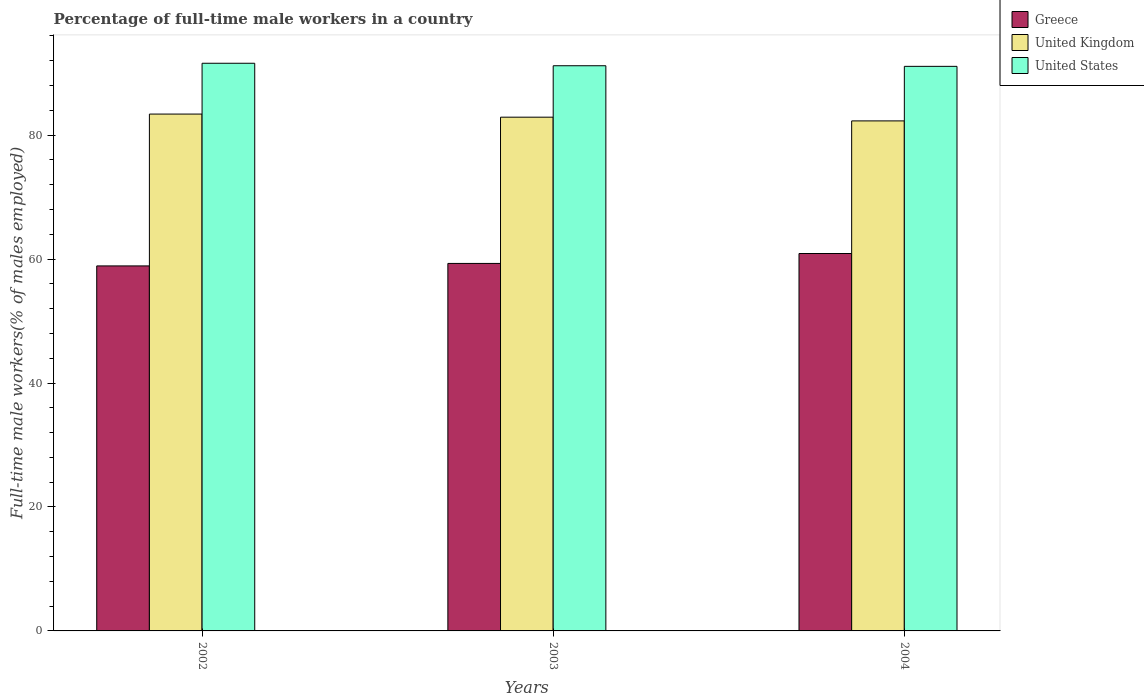How many groups of bars are there?
Give a very brief answer. 3. Are the number of bars per tick equal to the number of legend labels?
Your response must be concise. Yes. What is the percentage of full-time male workers in United Kingdom in 2003?
Provide a succinct answer. 82.9. Across all years, what is the maximum percentage of full-time male workers in Greece?
Provide a succinct answer. 60.9. Across all years, what is the minimum percentage of full-time male workers in United Kingdom?
Ensure brevity in your answer.  82.3. In which year was the percentage of full-time male workers in United States maximum?
Provide a short and direct response. 2002. In which year was the percentage of full-time male workers in United Kingdom minimum?
Your response must be concise. 2004. What is the total percentage of full-time male workers in United States in the graph?
Provide a succinct answer. 273.9. What is the difference between the percentage of full-time male workers in Greece in 2003 and the percentage of full-time male workers in United Kingdom in 2004?
Keep it short and to the point. -23. What is the average percentage of full-time male workers in United States per year?
Give a very brief answer. 91.3. In the year 2002, what is the difference between the percentage of full-time male workers in United States and percentage of full-time male workers in Greece?
Offer a very short reply. 32.7. In how many years, is the percentage of full-time male workers in Greece greater than 56 %?
Keep it short and to the point. 3. What is the ratio of the percentage of full-time male workers in Greece in 2002 to that in 2003?
Offer a terse response. 0.99. Is the percentage of full-time male workers in United Kingdom in 2003 less than that in 2004?
Offer a terse response. No. Is the difference between the percentage of full-time male workers in United States in 2002 and 2003 greater than the difference between the percentage of full-time male workers in Greece in 2002 and 2003?
Your answer should be compact. Yes. What is the difference between the highest and the second highest percentage of full-time male workers in Greece?
Ensure brevity in your answer.  1.6. What does the 2nd bar from the left in 2002 represents?
Provide a short and direct response. United Kingdom. How many bars are there?
Provide a short and direct response. 9. Are all the bars in the graph horizontal?
Offer a very short reply. No. What is the difference between two consecutive major ticks on the Y-axis?
Provide a short and direct response. 20. Does the graph contain grids?
Give a very brief answer. No. Where does the legend appear in the graph?
Your response must be concise. Top right. How many legend labels are there?
Give a very brief answer. 3. How are the legend labels stacked?
Keep it short and to the point. Vertical. What is the title of the graph?
Offer a very short reply. Percentage of full-time male workers in a country. Does "Iraq" appear as one of the legend labels in the graph?
Keep it short and to the point. No. What is the label or title of the X-axis?
Make the answer very short. Years. What is the label or title of the Y-axis?
Provide a short and direct response. Full-time male workers(% of males employed). What is the Full-time male workers(% of males employed) of Greece in 2002?
Ensure brevity in your answer.  58.9. What is the Full-time male workers(% of males employed) of United Kingdom in 2002?
Keep it short and to the point. 83.4. What is the Full-time male workers(% of males employed) of United States in 2002?
Offer a very short reply. 91.6. What is the Full-time male workers(% of males employed) in Greece in 2003?
Make the answer very short. 59.3. What is the Full-time male workers(% of males employed) in United Kingdom in 2003?
Make the answer very short. 82.9. What is the Full-time male workers(% of males employed) of United States in 2003?
Offer a very short reply. 91.2. What is the Full-time male workers(% of males employed) of Greece in 2004?
Provide a short and direct response. 60.9. What is the Full-time male workers(% of males employed) of United Kingdom in 2004?
Ensure brevity in your answer.  82.3. What is the Full-time male workers(% of males employed) in United States in 2004?
Offer a very short reply. 91.1. Across all years, what is the maximum Full-time male workers(% of males employed) in Greece?
Provide a succinct answer. 60.9. Across all years, what is the maximum Full-time male workers(% of males employed) in United Kingdom?
Offer a very short reply. 83.4. Across all years, what is the maximum Full-time male workers(% of males employed) in United States?
Offer a very short reply. 91.6. Across all years, what is the minimum Full-time male workers(% of males employed) of Greece?
Keep it short and to the point. 58.9. Across all years, what is the minimum Full-time male workers(% of males employed) of United Kingdom?
Your response must be concise. 82.3. Across all years, what is the minimum Full-time male workers(% of males employed) in United States?
Make the answer very short. 91.1. What is the total Full-time male workers(% of males employed) of Greece in the graph?
Give a very brief answer. 179.1. What is the total Full-time male workers(% of males employed) of United Kingdom in the graph?
Give a very brief answer. 248.6. What is the total Full-time male workers(% of males employed) in United States in the graph?
Make the answer very short. 273.9. What is the difference between the Full-time male workers(% of males employed) in United States in 2002 and that in 2004?
Ensure brevity in your answer.  0.5. What is the difference between the Full-time male workers(% of males employed) of Greece in 2002 and the Full-time male workers(% of males employed) of United Kingdom in 2003?
Give a very brief answer. -24. What is the difference between the Full-time male workers(% of males employed) in Greece in 2002 and the Full-time male workers(% of males employed) in United States in 2003?
Provide a succinct answer. -32.3. What is the difference between the Full-time male workers(% of males employed) in United Kingdom in 2002 and the Full-time male workers(% of males employed) in United States in 2003?
Your answer should be very brief. -7.8. What is the difference between the Full-time male workers(% of males employed) of Greece in 2002 and the Full-time male workers(% of males employed) of United Kingdom in 2004?
Offer a terse response. -23.4. What is the difference between the Full-time male workers(% of males employed) of Greece in 2002 and the Full-time male workers(% of males employed) of United States in 2004?
Give a very brief answer. -32.2. What is the difference between the Full-time male workers(% of males employed) in United Kingdom in 2002 and the Full-time male workers(% of males employed) in United States in 2004?
Provide a short and direct response. -7.7. What is the difference between the Full-time male workers(% of males employed) in Greece in 2003 and the Full-time male workers(% of males employed) in United States in 2004?
Ensure brevity in your answer.  -31.8. What is the average Full-time male workers(% of males employed) of Greece per year?
Make the answer very short. 59.7. What is the average Full-time male workers(% of males employed) of United Kingdom per year?
Ensure brevity in your answer.  82.87. What is the average Full-time male workers(% of males employed) in United States per year?
Give a very brief answer. 91.3. In the year 2002, what is the difference between the Full-time male workers(% of males employed) of Greece and Full-time male workers(% of males employed) of United Kingdom?
Ensure brevity in your answer.  -24.5. In the year 2002, what is the difference between the Full-time male workers(% of males employed) of Greece and Full-time male workers(% of males employed) of United States?
Offer a terse response. -32.7. In the year 2002, what is the difference between the Full-time male workers(% of males employed) in United Kingdom and Full-time male workers(% of males employed) in United States?
Provide a short and direct response. -8.2. In the year 2003, what is the difference between the Full-time male workers(% of males employed) of Greece and Full-time male workers(% of males employed) of United Kingdom?
Ensure brevity in your answer.  -23.6. In the year 2003, what is the difference between the Full-time male workers(% of males employed) in Greece and Full-time male workers(% of males employed) in United States?
Provide a succinct answer. -31.9. In the year 2004, what is the difference between the Full-time male workers(% of males employed) in Greece and Full-time male workers(% of males employed) in United Kingdom?
Make the answer very short. -21.4. In the year 2004, what is the difference between the Full-time male workers(% of males employed) in Greece and Full-time male workers(% of males employed) in United States?
Ensure brevity in your answer.  -30.2. In the year 2004, what is the difference between the Full-time male workers(% of males employed) of United Kingdom and Full-time male workers(% of males employed) of United States?
Make the answer very short. -8.8. What is the ratio of the Full-time male workers(% of males employed) of United Kingdom in 2002 to that in 2003?
Your answer should be compact. 1.01. What is the ratio of the Full-time male workers(% of males employed) in Greece in 2002 to that in 2004?
Keep it short and to the point. 0.97. What is the ratio of the Full-time male workers(% of males employed) in United Kingdom in 2002 to that in 2004?
Your answer should be compact. 1.01. What is the ratio of the Full-time male workers(% of males employed) in Greece in 2003 to that in 2004?
Your response must be concise. 0.97. What is the ratio of the Full-time male workers(% of males employed) in United Kingdom in 2003 to that in 2004?
Keep it short and to the point. 1.01. What is the difference between the highest and the second highest Full-time male workers(% of males employed) in United Kingdom?
Give a very brief answer. 0.5. What is the difference between the highest and the lowest Full-time male workers(% of males employed) of Greece?
Provide a succinct answer. 2. What is the difference between the highest and the lowest Full-time male workers(% of males employed) of United States?
Your answer should be compact. 0.5. 